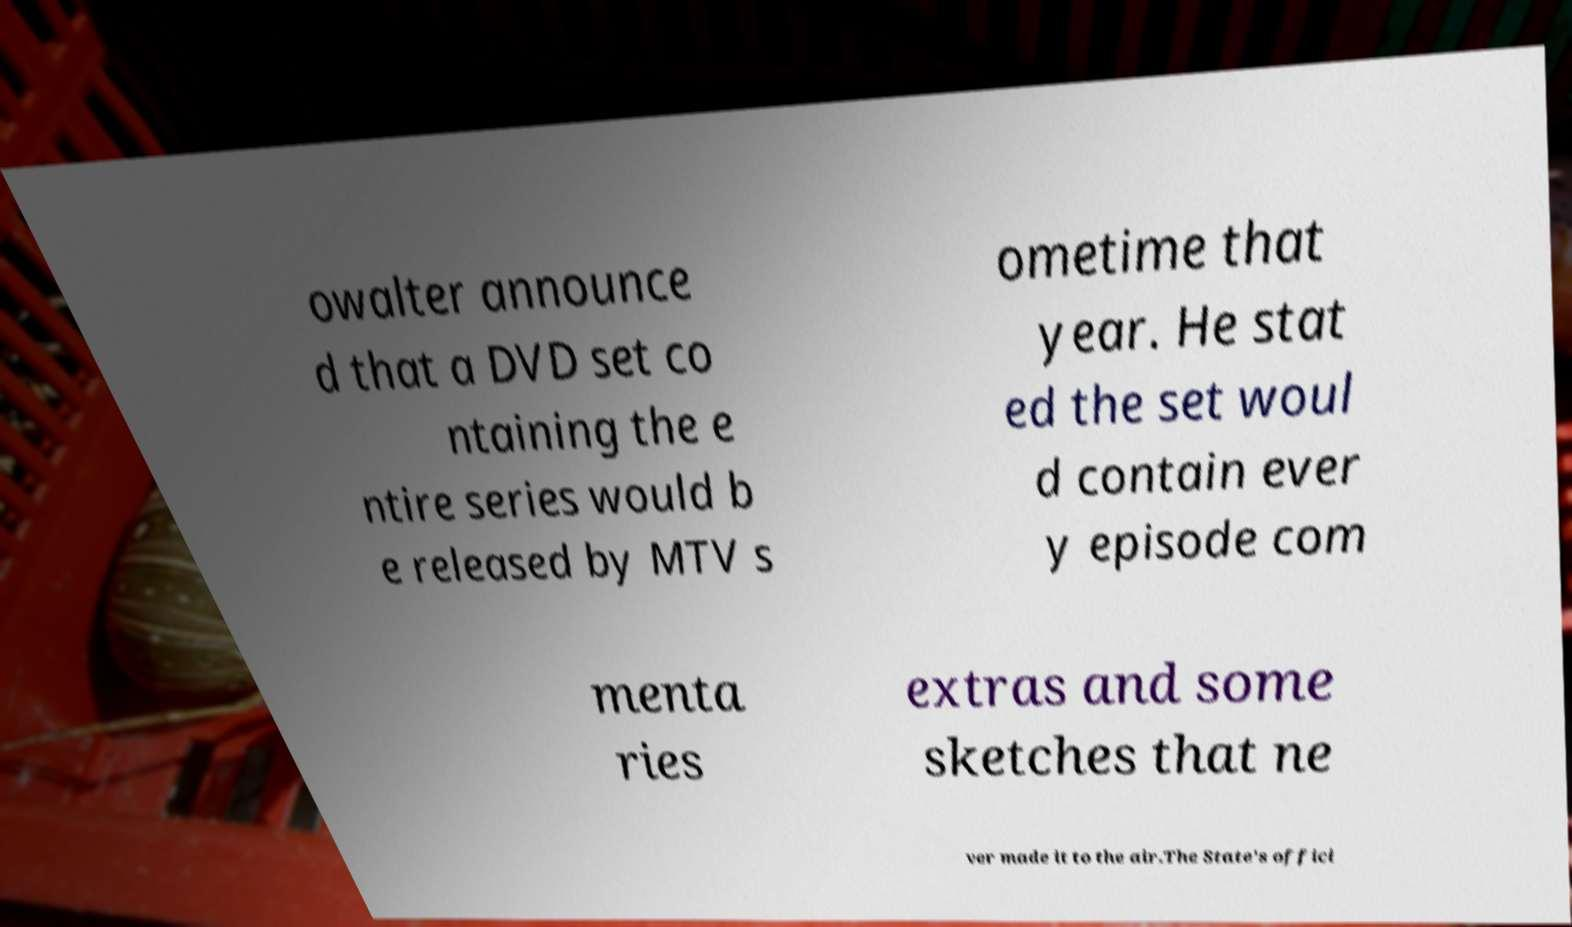Please identify and transcribe the text found in this image. owalter announce d that a DVD set co ntaining the e ntire series would b e released by MTV s ometime that year. He stat ed the set woul d contain ever y episode com menta ries extras and some sketches that ne ver made it to the air.The State's offici 